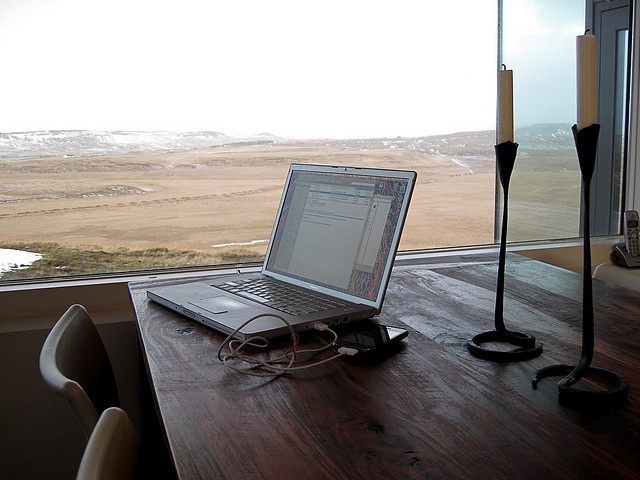Describe the objects in this image and their specific colors. I can see dining table in white, black, gray, and darkgray tones, laptop in white, gray, and black tones, chair in white, black, and gray tones, chair in white, black, and gray tones, and cell phone in white, black, darkgray, lightgray, and gray tones in this image. 